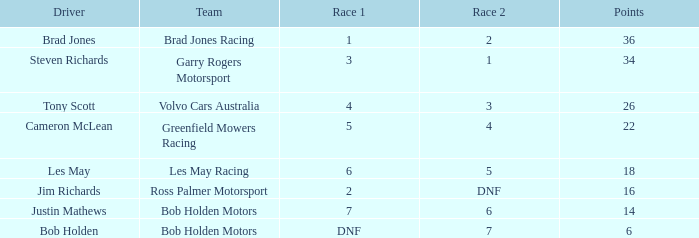Which team received 4 in race 1? Volvo Cars Australia. 